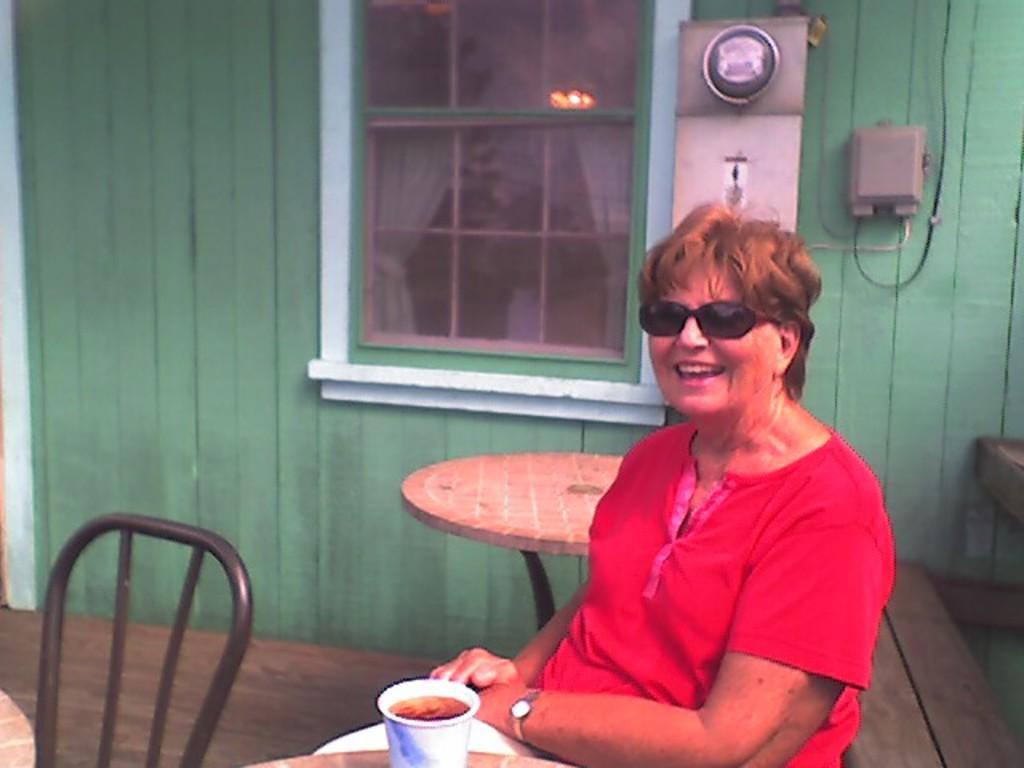How would you summarize this image in a sentence or two? In the picture we can see a woman wearing glasses and she is laughing,in front of her there was table,on that table there was a glass with some liquid, back of woman there was a wall and there was a window with a curtain. 